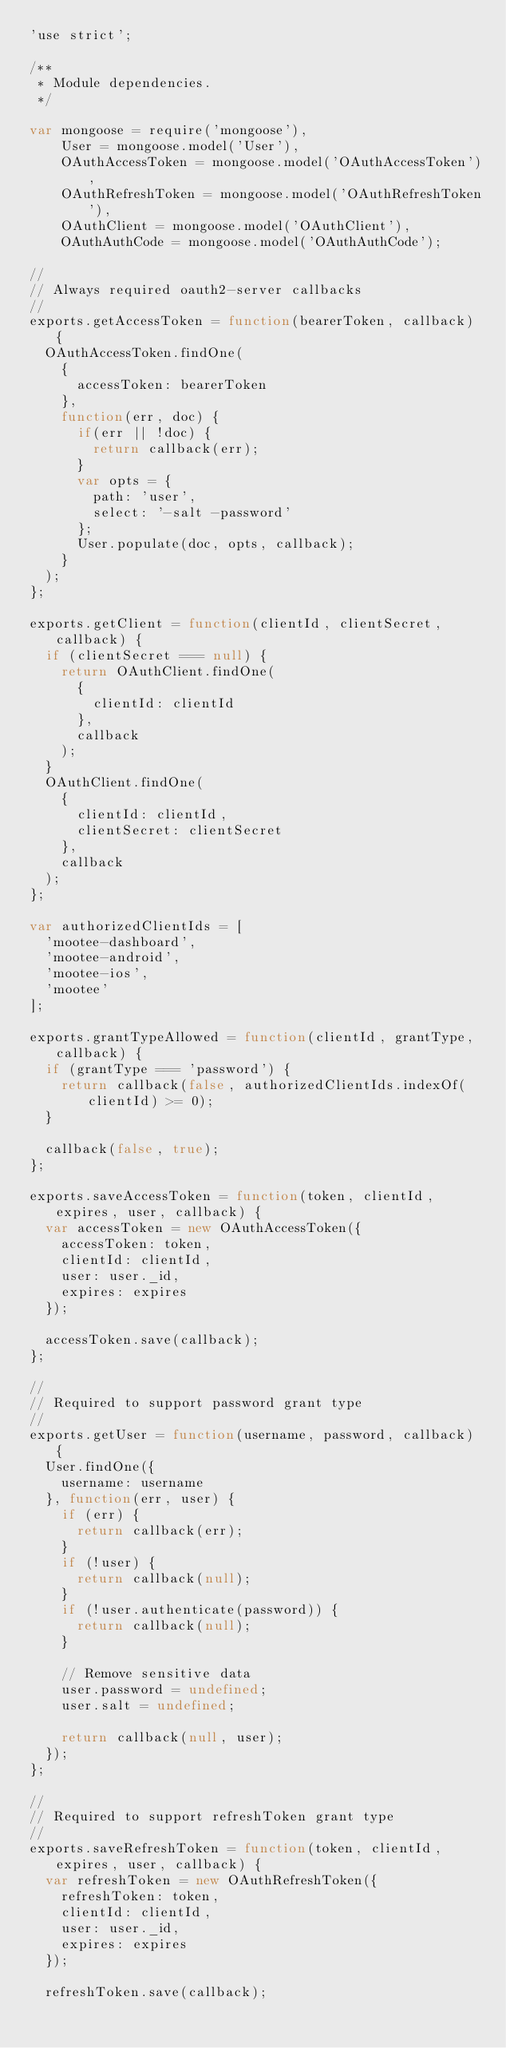Convert code to text. <code><loc_0><loc_0><loc_500><loc_500><_JavaScript_>'use strict';

/**
 * Module dependencies.
 */

var mongoose = require('mongoose'),
    User = mongoose.model('User'),
    OAuthAccessToken = mongoose.model('OAuthAccessToken'),
    OAuthRefreshToken = mongoose.model('OAuthRefreshToken'),
    OAuthClient = mongoose.model('OAuthClient'),
    OAuthAuthCode = mongoose.model('OAuthAuthCode');

//
// Always required oauth2-server callbacks
//
exports.getAccessToken = function(bearerToken, callback) {
  OAuthAccessToken.findOne(
    {
      accessToken: bearerToken
    },
    function(err, doc) {
      if(err || !doc) {
        return callback(err);
      }
      var opts = {
        path: 'user',
        select: '-salt -password'
      };
      User.populate(doc, opts, callback);
    }
  );
};

exports.getClient = function(clientId, clientSecret, callback) {
  if (clientSecret === null) {
    return OAuthClient.findOne(
      {
        clientId: clientId
      },
      callback
    );
  }
  OAuthClient.findOne(
    {
      clientId: clientId,
      clientSecret: clientSecret
    },
    callback
  );
};

var authorizedClientIds = [
  'mootee-dashboard',
  'mootee-android',
  'mootee-ios',
  'mootee'
];

exports.grantTypeAllowed = function(clientId, grantType, callback) {
  if (grantType === 'password') {
    return callback(false, authorizedClientIds.indexOf(clientId) >= 0);
  }

  callback(false, true);
};

exports.saveAccessToken = function(token, clientId, expires, user, callback) {
  var accessToken = new OAuthAccessToken({
    accessToken: token,
    clientId: clientId,
    user: user._id,
    expires: expires
  });

  accessToken.save(callback);
};

//
// Required to support password grant type
//
exports.getUser = function(username, password, callback) {
  User.findOne({
    username: username
  }, function(err, user) {
    if (err) {
      return callback(err);
    }
    if (!user) {
      return callback(null);
    }
    if (!user.authenticate(password)) {
      return callback(null);
    }

    // Remove sensitive data
    user.password = undefined;
    user.salt = undefined;

    return callback(null, user);
  });
};

//
// Required to support refreshToken grant type
//
exports.saveRefreshToken = function(token, clientId, expires, user, callback) {
  var refreshToken = new OAuthRefreshToken({
    refreshToken: token,
    clientId: clientId,
    user: user._id,
    expires: expires
  });

  refreshToken.save(callback);</code> 